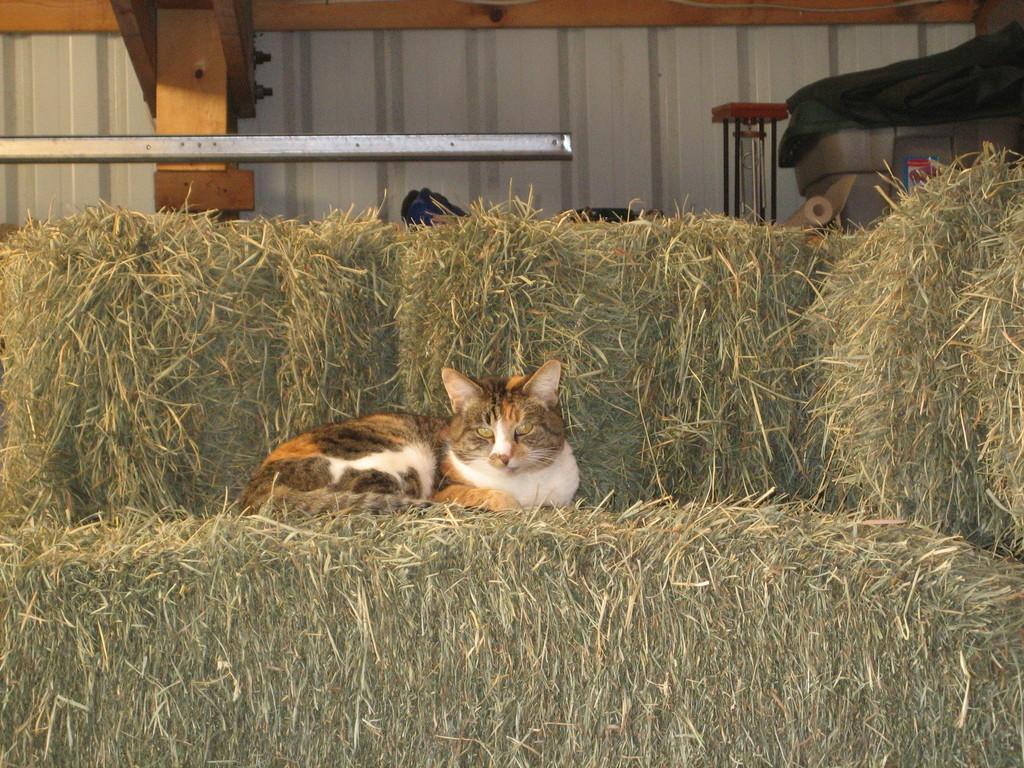Please provide a concise description of this image. This is a cat sitting on the dried grass. I can see few objects placed here. This looks like an iron sheet. I can see a pillar. 